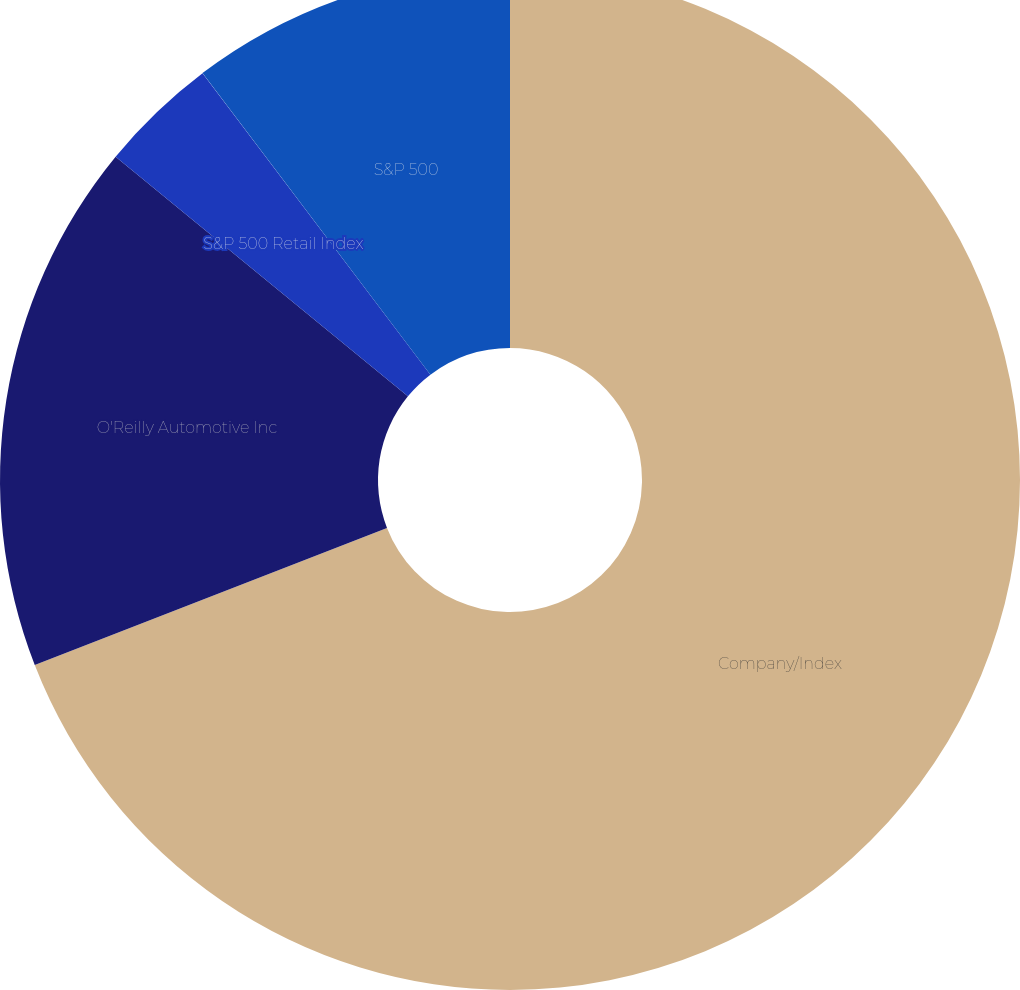<chart> <loc_0><loc_0><loc_500><loc_500><pie_chart><fcel>Company/Index<fcel>O'Reilly Automotive Inc<fcel>S&P 500 Retail Index<fcel>S&P 500<nl><fcel>69.09%<fcel>16.84%<fcel>3.77%<fcel>10.3%<nl></chart> 